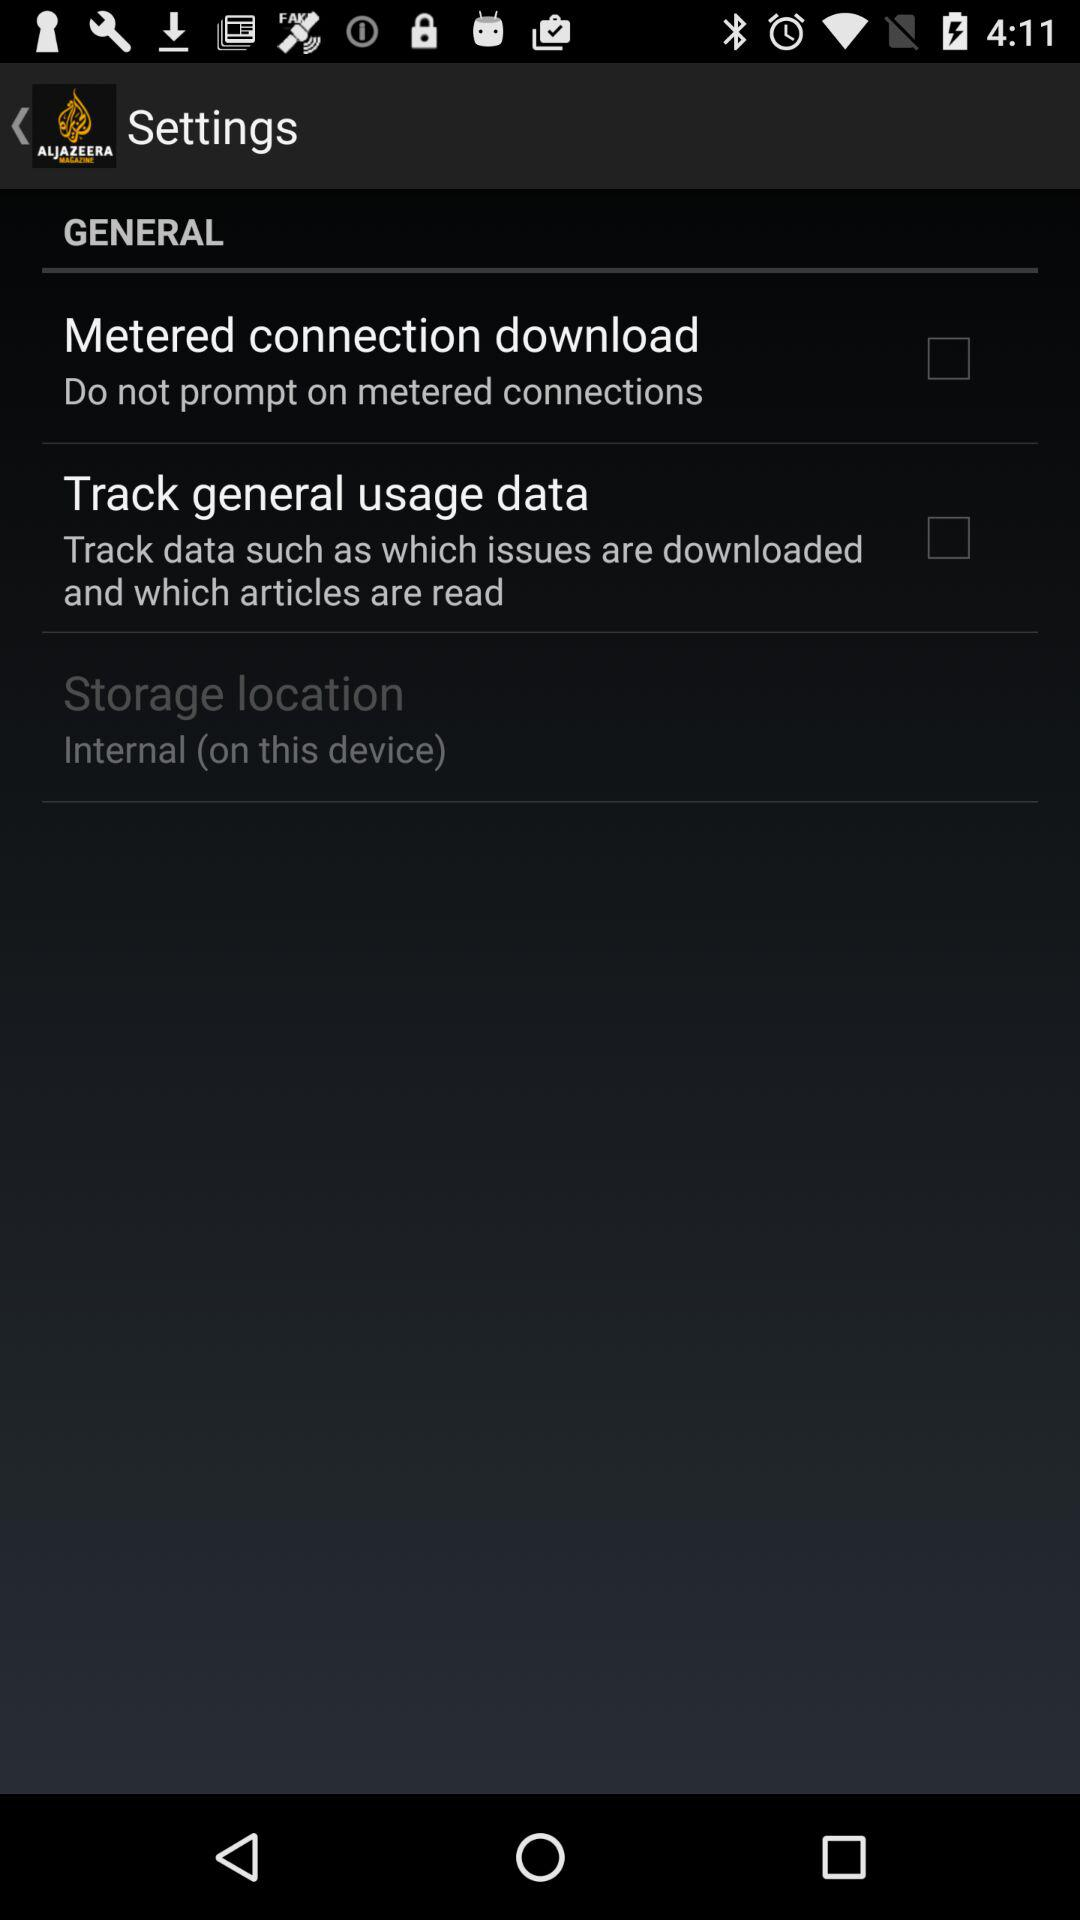Is "Storage location" checked or unchecked?
When the provided information is insufficient, respond with <no answer>. <no answer> 